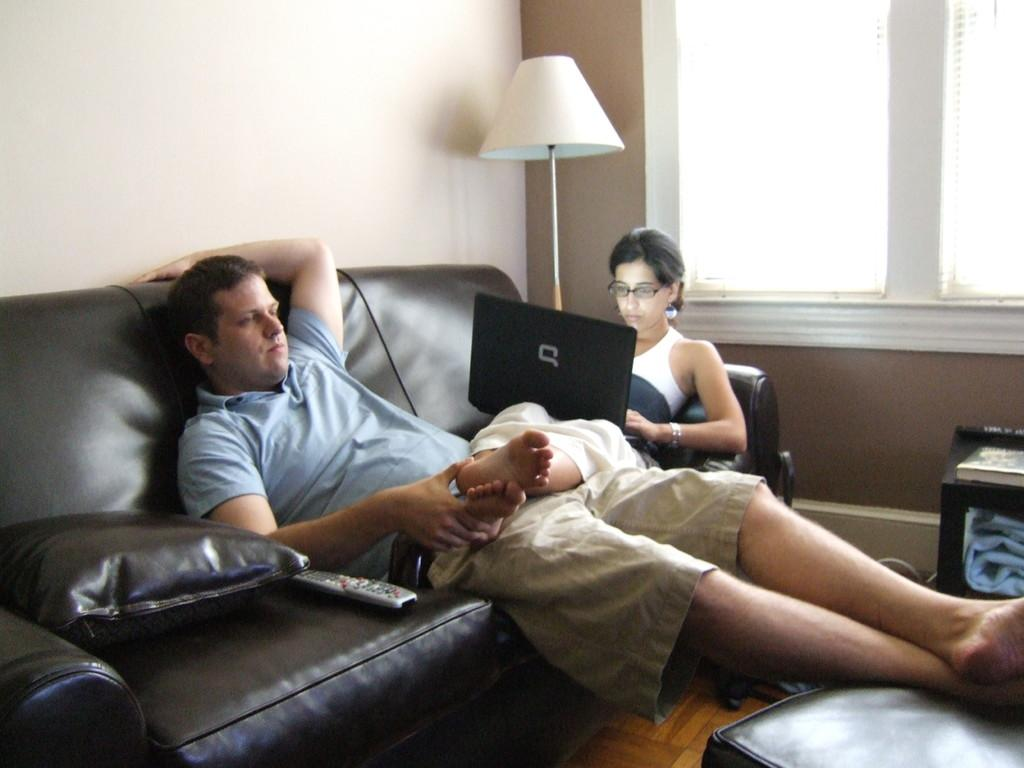Who or what can be seen in the image? There are people in the image. What are the people doing in the image? The people are sitting on a sofa. What type of rice is being served on the twig in the image? There is no rice or twig present in the image; it only features people sitting on a sofa. 